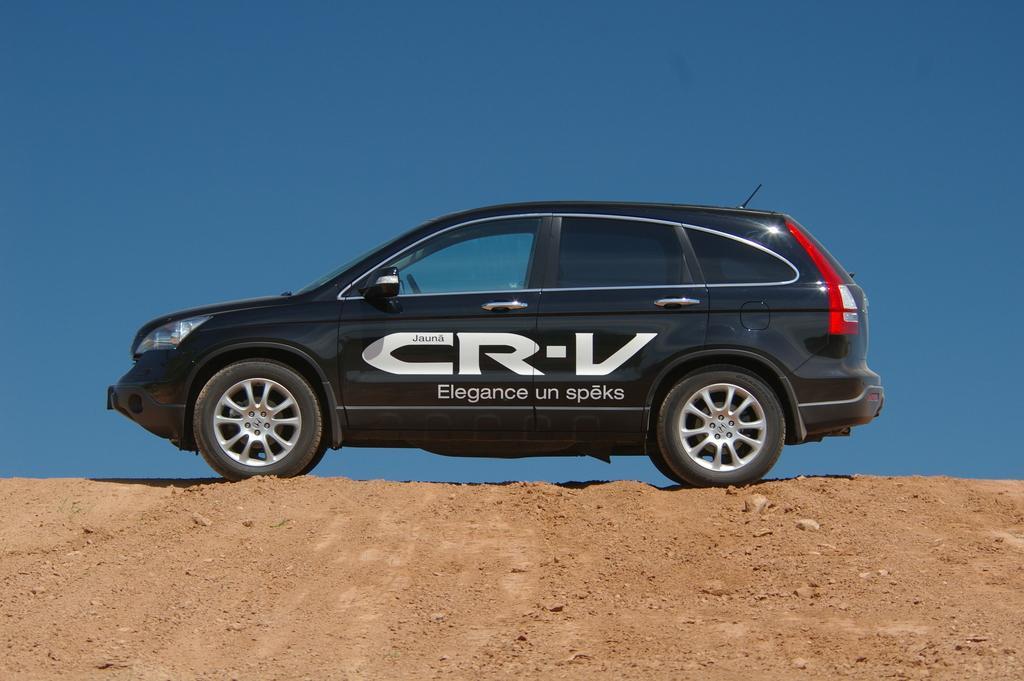Describe this image in one or two sentences. In the picture we can see a car on the mud surface, the car is black color and name on it CR-V and behind the car we can see the sky which is blue in color. 